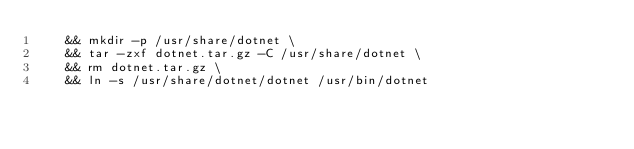<code> <loc_0><loc_0><loc_500><loc_500><_Dockerfile_>    && mkdir -p /usr/share/dotnet \
    && tar -zxf dotnet.tar.gz -C /usr/share/dotnet \
    && rm dotnet.tar.gz \
    && ln -s /usr/share/dotnet/dotnet /usr/bin/dotnet
</code> 